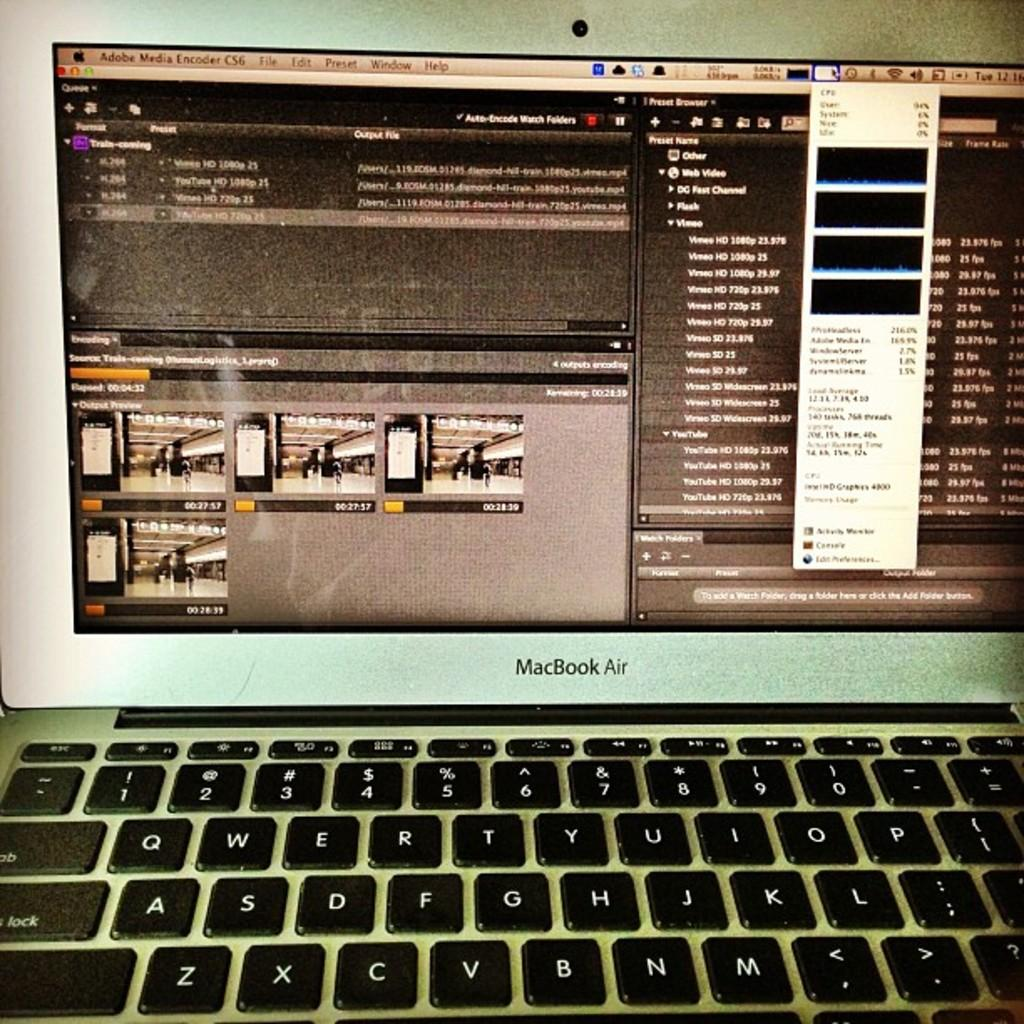Provide a one-sentence caption for the provided image. Part of an open and turned on MacBook Air. 